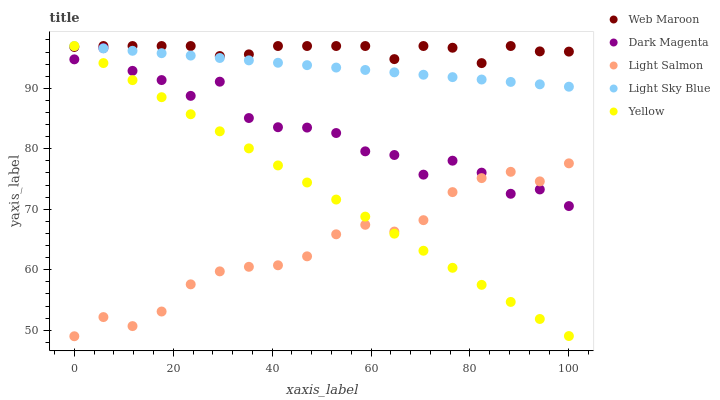Does Light Salmon have the minimum area under the curve?
Answer yes or no. Yes. Does Web Maroon have the maximum area under the curve?
Answer yes or no. Yes. Does Light Sky Blue have the minimum area under the curve?
Answer yes or no. No. Does Light Sky Blue have the maximum area under the curve?
Answer yes or no. No. Is Light Sky Blue the smoothest?
Answer yes or no. Yes. Is Dark Magenta the roughest?
Answer yes or no. Yes. Is Web Maroon the smoothest?
Answer yes or no. No. Is Web Maroon the roughest?
Answer yes or no. No. Does Light Salmon have the lowest value?
Answer yes or no. Yes. Does Light Sky Blue have the lowest value?
Answer yes or no. No. Does Yellow have the highest value?
Answer yes or no. Yes. Does Dark Magenta have the highest value?
Answer yes or no. No. Is Light Salmon less than Light Sky Blue?
Answer yes or no. Yes. Is Light Sky Blue greater than Light Salmon?
Answer yes or no. Yes. Does Dark Magenta intersect Light Sky Blue?
Answer yes or no. Yes. Is Dark Magenta less than Light Sky Blue?
Answer yes or no. No. Is Dark Magenta greater than Light Sky Blue?
Answer yes or no. No. Does Light Salmon intersect Light Sky Blue?
Answer yes or no. No. 